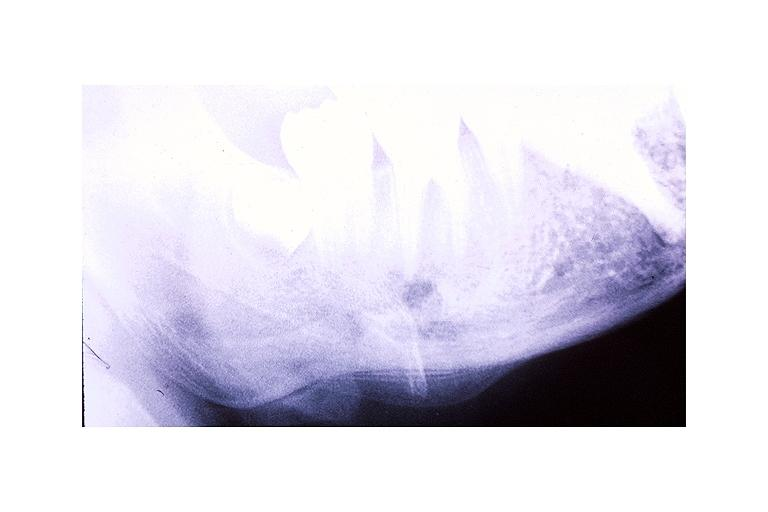does granulosa cell tumor show garres osteomyelitis proliferative periosteitis?
Answer the question using a single word or phrase. No 